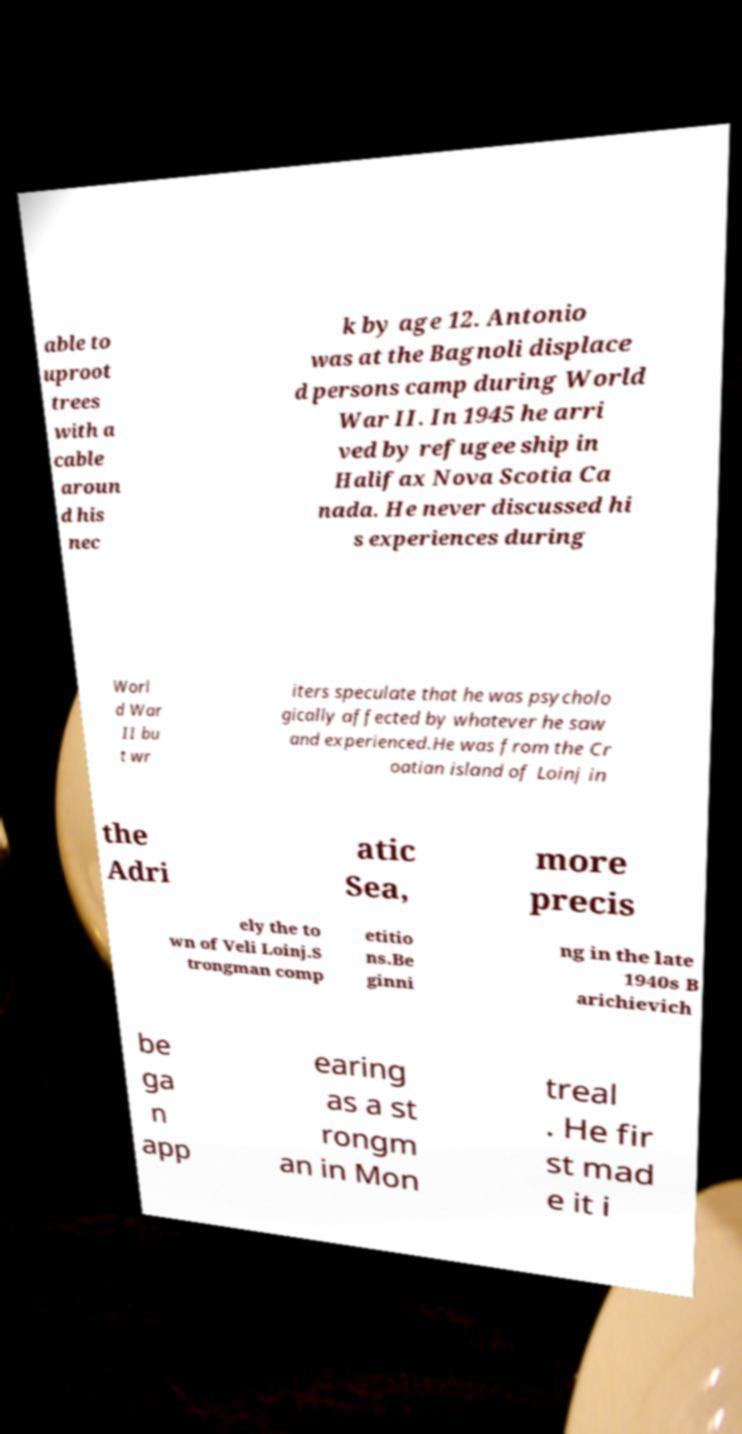Please read and relay the text visible in this image. What does it say? able to uproot trees with a cable aroun d his nec k by age 12. Antonio was at the Bagnoli displace d persons camp during World War II. In 1945 he arri ved by refugee ship in Halifax Nova Scotia Ca nada. He never discussed hi s experiences during Worl d War II bu t wr iters speculate that he was psycholo gically affected by whatever he saw and experienced.He was from the Cr oatian island of Loinj in the Adri atic Sea, more precis ely the to wn of Veli Loinj.S trongman comp etitio ns.Be ginni ng in the late 1940s B arichievich be ga n app earing as a st rongm an in Mon treal . He fir st mad e it i 